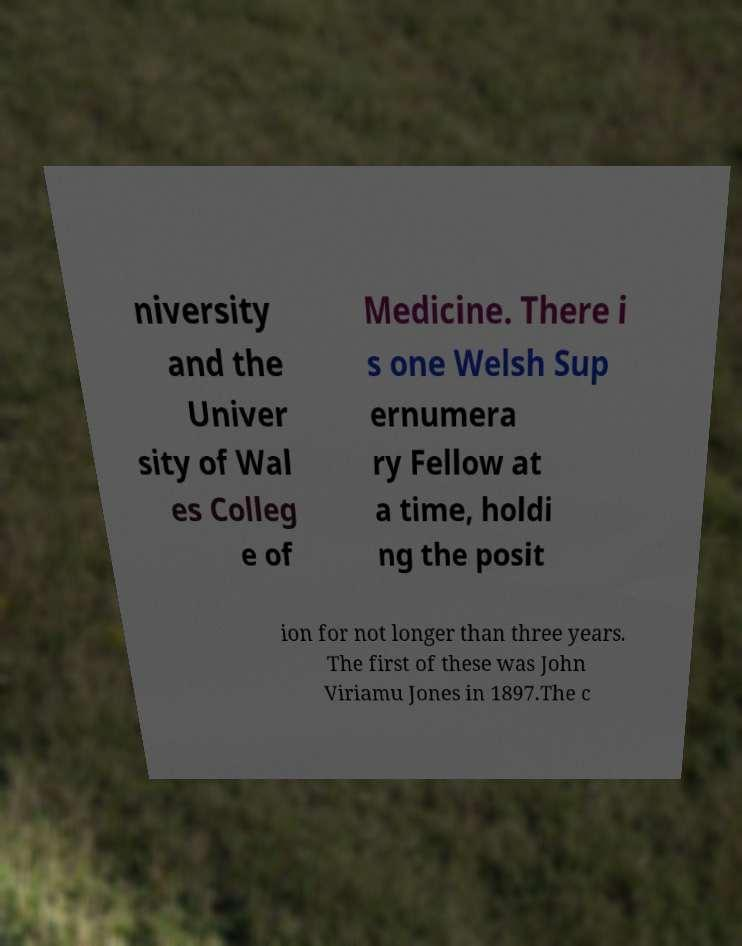Could you extract and type out the text from this image? niversity and the Univer sity of Wal es Colleg e of Medicine. There i s one Welsh Sup ernumera ry Fellow at a time, holdi ng the posit ion for not longer than three years. The first of these was John Viriamu Jones in 1897.The c 